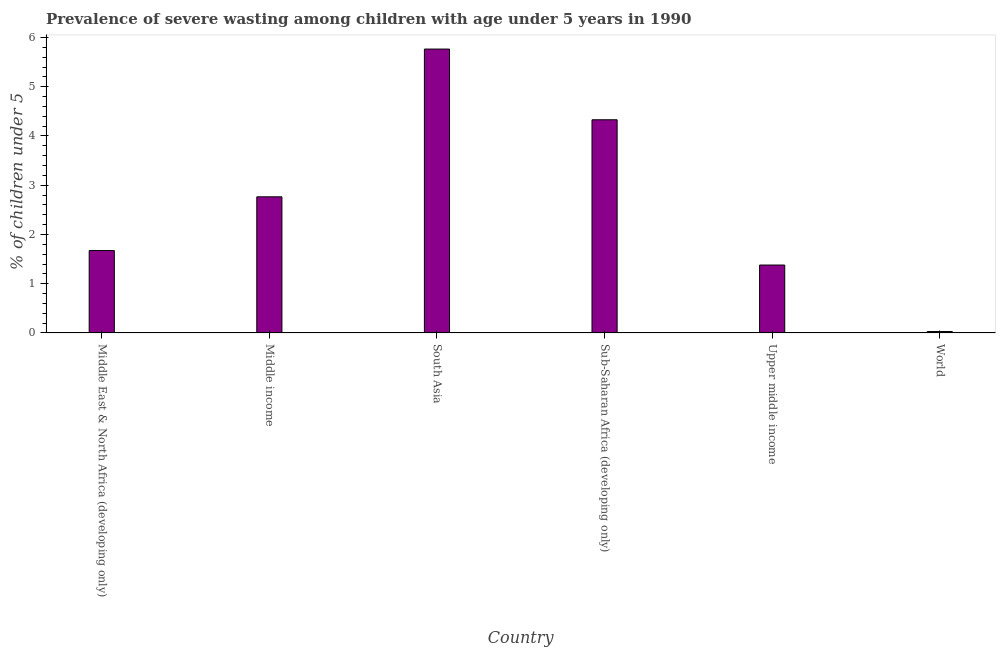Does the graph contain grids?
Provide a succinct answer. No. What is the title of the graph?
Provide a short and direct response. Prevalence of severe wasting among children with age under 5 years in 1990. What is the label or title of the Y-axis?
Offer a very short reply.  % of children under 5. What is the prevalence of severe wasting in Middle income?
Your response must be concise. 2.76. Across all countries, what is the maximum prevalence of severe wasting?
Offer a terse response. 5.77. Across all countries, what is the minimum prevalence of severe wasting?
Provide a short and direct response. 0.03. In which country was the prevalence of severe wasting maximum?
Give a very brief answer. South Asia. What is the sum of the prevalence of severe wasting?
Make the answer very short. 15.94. What is the difference between the prevalence of severe wasting in Middle East & North Africa (developing only) and South Asia?
Your answer should be compact. -4.09. What is the average prevalence of severe wasting per country?
Offer a very short reply. 2.66. What is the median prevalence of severe wasting?
Offer a very short reply. 2.22. What is the ratio of the prevalence of severe wasting in South Asia to that in Sub-Saharan Africa (developing only)?
Your answer should be very brief. 1.33. Is the prevalence of severe wasting in Middle East & North Africa (developing only) less than that in Upper middle income?
Provide a succinct answer. No. Is the difference between the prevalence of severe wasting in Sub-Saharan Africa (developing only) and World greater than the difference between any two countries?
Your answer should be very brief. No. What is the difference between the highest and the second highest prevalence of severe wasting?
Your answer should be very brief. 1.44. Is the sum of the prevalence of severe wasting in South Asia and Upper middle income greater than the maximum prevalence of severe wasting across all countries?
Offer a very short reply. Yes. What is the difference between the highest and the lowest prevalence of severe wasting?
Ensure brevity in your answer.  5.74. How many bars are there?
Provide a short and direct response. 6. Are all the bars in the graph horizontal?
Give a very brief answer. No. Are the values on the major ticks of Y-axis written in scientific E-notation?
Your answer should be very brief. No. What is the  % of children under 5 in Middle East & North Africa (developing only)?
Your answer should be very brief. 1.67. What is the  % of children under 5 of Middle income?
Provide a succinct answer. 2.76. What is the  % of children under 5 in South Asia?
Provide a short and direct response. 5.77. What is the  % of children under 5 in Sub-Saharan Africa (developing only)?
Ensure brevity in your answer.  4.33. What is the  % of children under 5 of Upper middle income?
Offer a terse response. 1.38. What is the  % of children under 5 of World?
Your answer should be very brief. 0.03. What is the difference between the  % of children under 5 in Middle East & North Africa (developing only) and Middle income?
Offer a very short reply. -1.09. What is the difference between the  % of children under 5 in Middle East & North Africa (developing only) and South Asia?
Your answer should be compact. -4.09. What is the difference between the  % of children under 5 in Middle East & North Africa (developing only) and Sub-Saharan Africa (developing only)?
Offer a terse response. -2.66. What is the difference between the  % of children under 5 in Middle East & North Africa (developing only) and Upper middle income?
Keep it short and to the point. 0.29. What is the difference between the  % of children under 5 in Middle East & North Africa (developing only) and World?
Your response must be concise. 1.64. What is the difference between the  % of children under 5 in Middle income and South Asia?
Provide a short and direct response. -3. What is the difference between the  % of children under 5 in Middle income and Sub-Saharan Africa (developing only)?
Give a very brief answer. -1.56. What is the difference between the  % of children under 5 in Middle income and Upper middle income?
Your response must be concise. 1.39. What is the difference between the  % of children under 5 in Middle income and World?
Offer a very short reply. 2.74. What is the difference between the  % of children under 5 in South Asia and Sub-Saharan Africa (developing only)?
Give a very brief answer. 1.44. What is the difference between the  % of children under 5 in South Asia and Upper middle income?
Keep it short and to the point. 4.39. What is the difference between the  % of children under 5 in South Asia and World?
Make the answer very short. 5.74. What is the difference between the  % of children under 5 in Sub-Saharan Africa (developing only) and Upper middle income?
Provide a short and direct response. 2.95. What is the difference between the  % of children under 5 in Sub-Saharan Africa (developing only) and World?
Offer a terse response. 4.3. What is the difference between the  % of children under 5 in Upper middle income and World?
Your response must be concise. 1.35. What is the ratio of the  % of children under 5 in Middle East & North Africa (developing only) to that in Middle income?
Make the answer very short. 0.6. What is the ratio of the  % of children under 5 in Middle East & North Africa (developing only) to that in South Asia?
Keep it short and to the point. 0.29. What is the ratio of the  % of children under 5 in Middle East & North Africa (developing only) to that in Sub-Saharan Africa (developing only)?
Keep it short and to the point. 0.39. What is the ratio of the  % of children under 5 in Middle East & North Africa (developing only) to that in Upper middle income?
Offer a very short reply. 1.21. What is the ratio of the  % of children under 5 in Middle East & North Africa (developing only) to that in World?
Give a very brief answer. 58.76. What is the ratio of the  % of children under 5 in Middle income to that in South Asia?
Your answer should be very brief. 0.48. What is the ratio of the  % of children under 5 in Middle income to that in Sub-Saharan Africa (developing only)?
Provide a succinct answer. 0.64. What is the ratio of the  % of children under 5 in Middle income to that in Upper middle income?
Provide a succinct answer. 2. What is the ratio of the  % of children under 5 in Middle income to that in World?
Offer a terse response. 97.09. What is the ratio of the  % of children under 5 in South Asia to that in Sub-Saharan Africa (developing only)?
Make the answer very short. 1.33. What is the ratio of the  % of children under 5 in South Asia to that in Upper middle income?
Your answer should be compact. 4.18. What is the ratio of the  % of children under 5 in South Asia to that in World?
Provide a short and direct response. 202.48. What is the ratio of the  % of children under 5 in Sub-Saharan Africa (developing only) to that in Upper middle income?
Make the answer very short. 3.14. What is the ratio of the  % of children under 5 in Sub-Saharan Africa (developing only) to that in World?
Offer a very short reply. 152.05. What is the ratio of the  % of children under 5 in Upper middle income to that in World?
Make the answer very short. 48.43. 